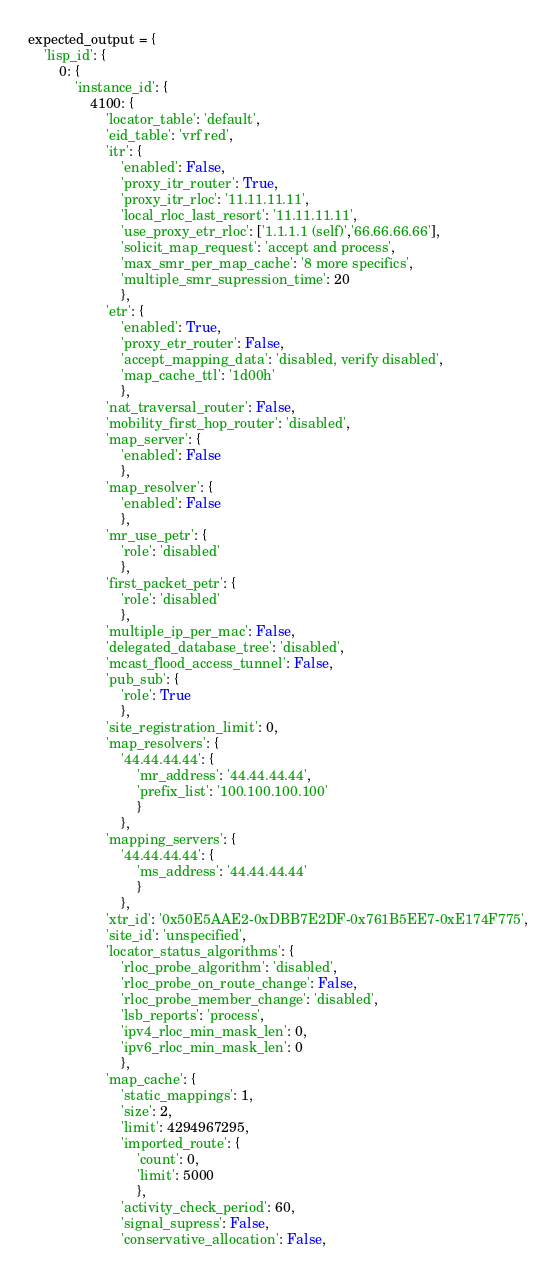Convert code to text. <code><loc_0><loc_0><loc_500><loc_500><_Python_>expected_output = {
    'lisp_id': {
        0: {
            'instance_id': {
                4100: {
                    'locator_table': 'default',
                    'eid_table': 'vrf red',
                    'itr': {
                        'enabled': False,
                        'proxy_itr_router': True,
                        'proxy_itr_rloc': '11.11.11.11',
                        'local_rloc_last_resort': '11.11.11.11',
                        'use_proxy_etr_rloc': ['1.1.1.1 (self)','66.66.66.66'],
                        'solicit_map_request': 'accept and process',
                        'max_smr_per_map_cache': '8 more specifics',
                        'multiple_smr_supression_time': 20
                        },
                    'etr': {
                        'enabled': True,
                        'proxy_etr_router': False,
                        'accept_mapping_data': 'disabled, verify disabled',
                        'map_cache_ttl': '1d00h'
                        },
                    'nat_traversal_router': False,
                    'mobility_first_hop_router': 'disabled',
                    'map_server': {
                        'enabled': False
                        },
                    'map_resolver': {
                        'enabled': False
                        },
                    'mr_use_petr': {
                        'role': 'disabled'
                        },
                    'first_packet_petr': {
                        'role': 'disabled'
                        },
                    'multiple_ip_per_mac': False,
                    'delegated_database_tree': 'disabled',
                    'mcast_flood_access_tunnel': False,
                    'pub_sub': {
                        'role': True
                        },
                    'site_registration_limit': 0,
                    'map_resolvers': {
                        '44.44.44.44': {
                            'mr_address': '44.44.44.44',
                            'prefix_list': '100.100.100.100'
                            }
                        },
                    'mapping_servers': {
                        '44.44.44.44': {
                            'ms_address': '44.44.44.44'
                            }
                        },
                    'xtr_id': '0x50E5AAE2-0xDBB7E2DF-0x761B5EE7-0xE174F775',
                    'site_id': 'unspecified',
                    'locator_status_algorithms': {
                        'rloc_probe_algorithm': 'disabled',
                        'rloc_probe_on_route_change': False,
                        'rloc_probe_member_change': 'disabled',
                        'lsb_reports': 'process',
                        'ipv4_rloc_min_mask_len': 0,
                        'ipv6_rloc_min_mask_len': 0
                        },
                    'map_cache': {
                        'static_mappings': 1,
                        'size': 2,
                        'limit': 4294967295,
                        'imported_route': {
                            'count': 0,
                            'limit': 5000
                            },
                        'activity_check_period': 60,
                        'signal_supress': False,
                        'conservative_allocation': False,</code> 